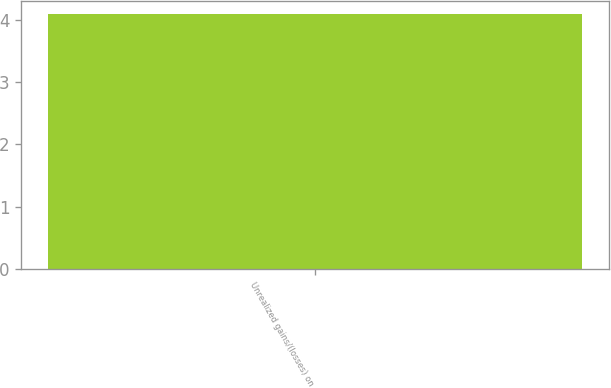Convert chart. <chart><loc_0><loc_0><loc_500><loc_500><bar_chart><fcel>Unrealized gains/(losses) on<nl><fcel>4.1<nl></chart> 